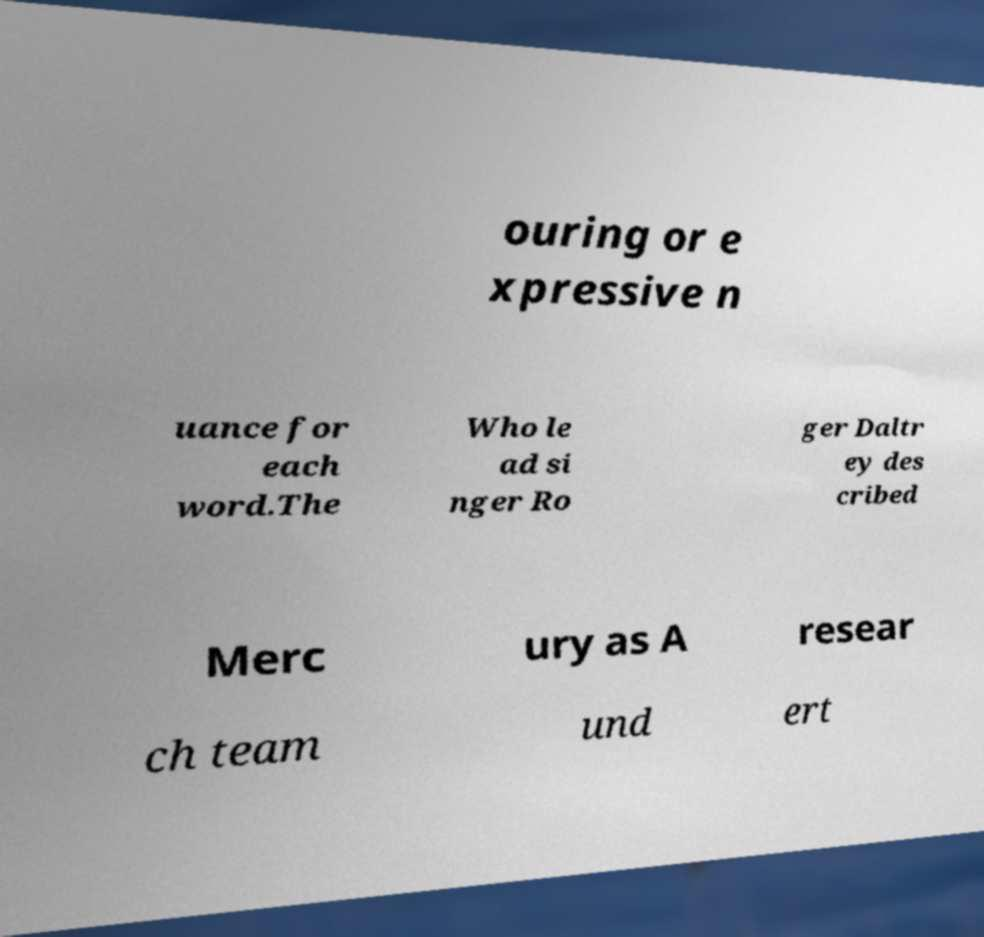Could you extract and type out the text from this image? ouring or e xpressive n uance for each word.The Who le ad si nger Ro ger Daltr ey des cribed Merc ury as A resear ch team und ert 